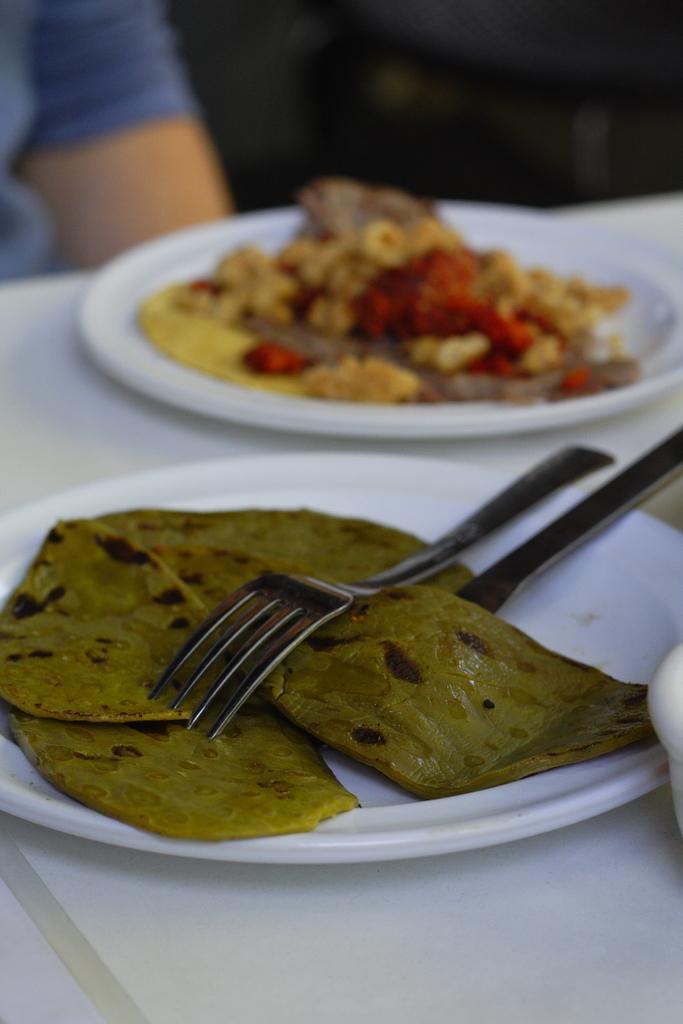How would you summarize this image in a sentence or two? In this image there are food items are placed on two plates. In the one of the plates there are forks, which are arranged on a table. In front of the table there is a person sitting. 